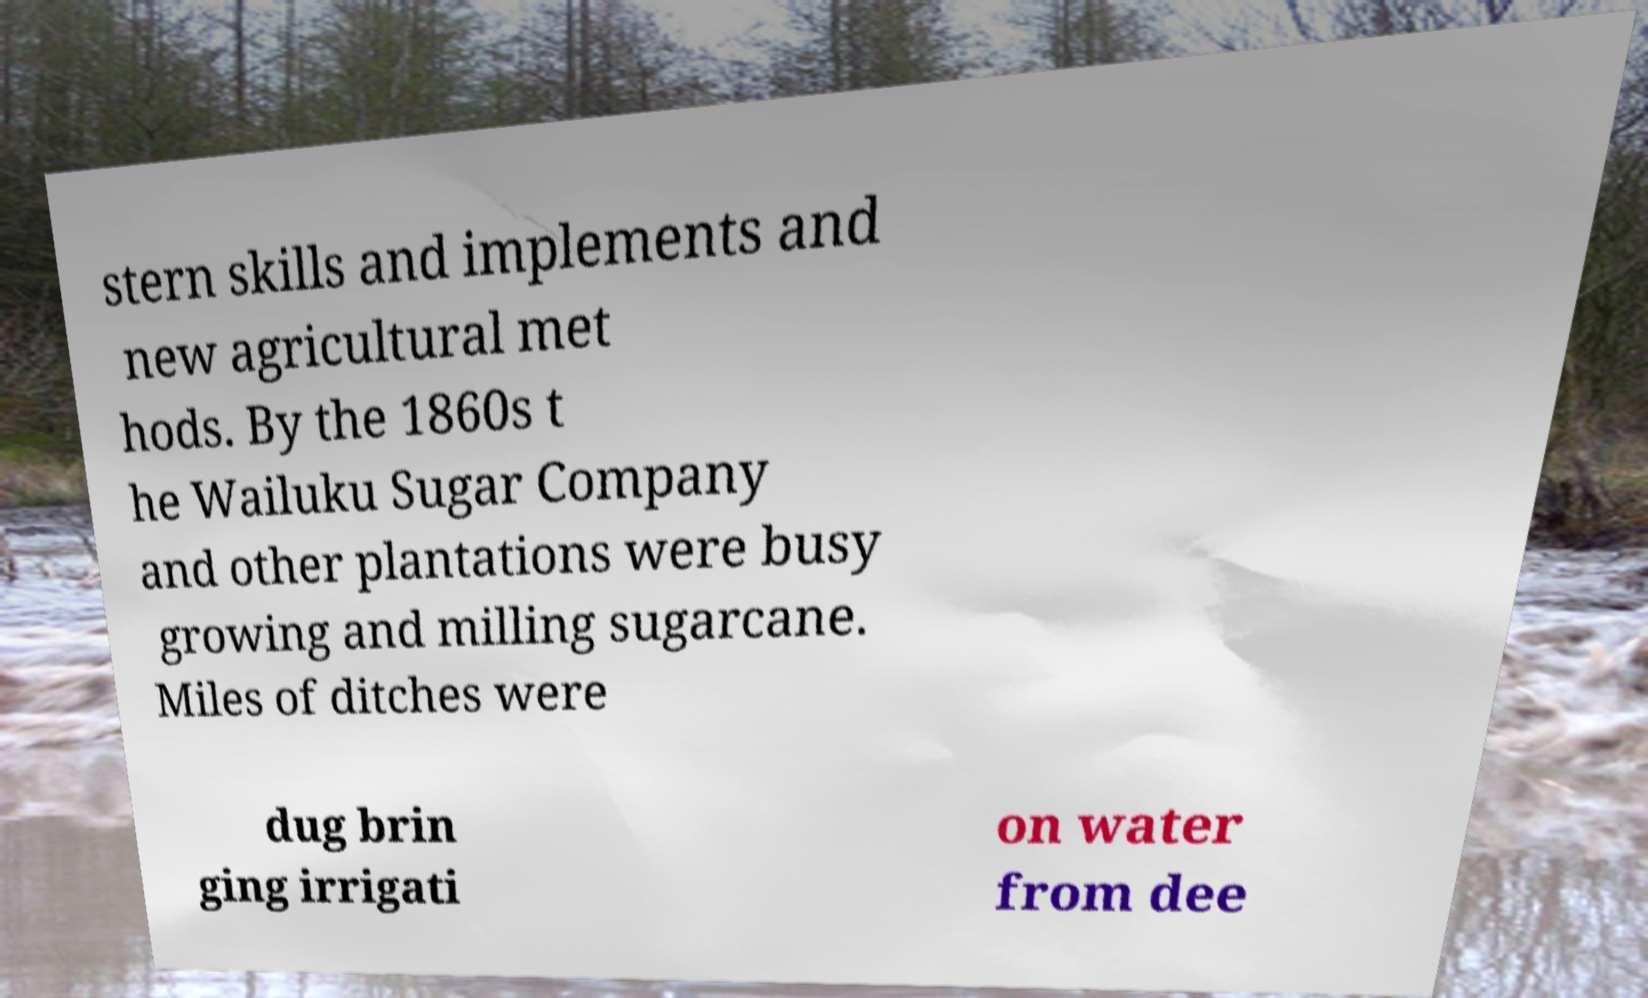Please read and relay the text visible in this image. What does it say? stern skills and implements and new agricultural met hods. By the 1860s t he Wailuku Sugar Company and other plantations were busy growing and milling sugarcane. Miles of ditches were dug brin ging irrigati on water from dee 